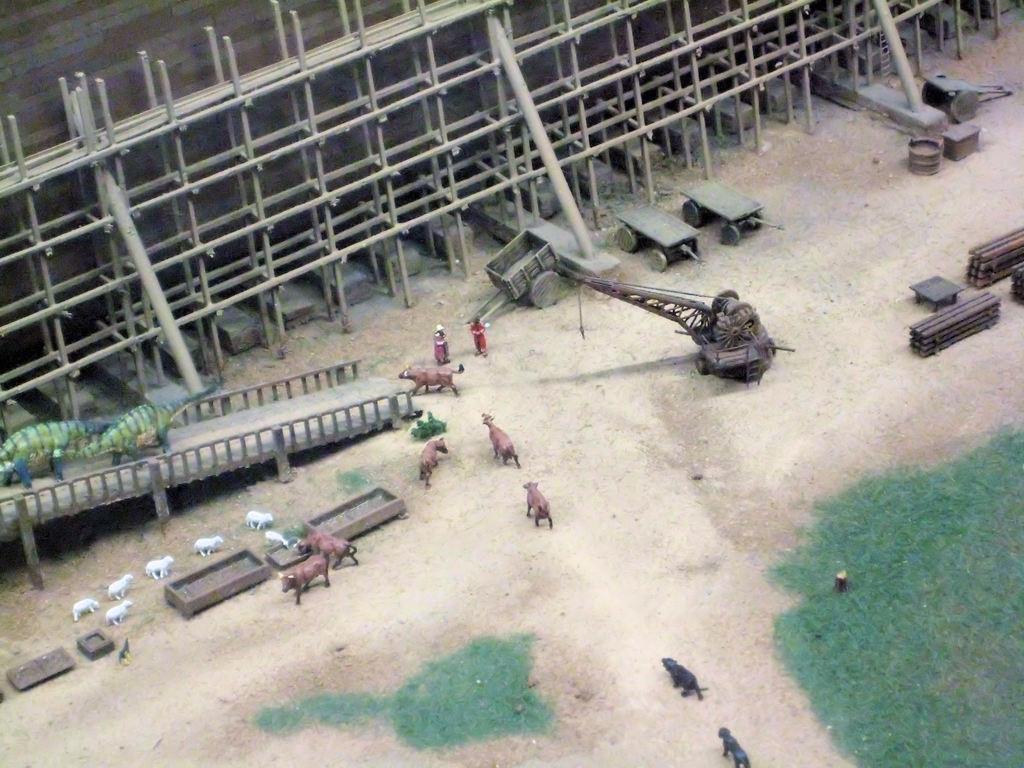Please provide a concise description of this image. In this picture I can see toys, poles, wall, grass and some other objects. 